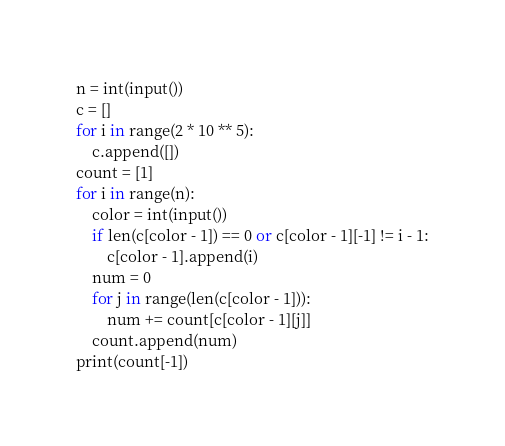Convert code to text. <code><loc_0><loc_0><loc_500><loc_500><_Python_>n = int(input())
c = []
for i in range(2 * 10 ** 5):
    c.append([])
count = [1]
for i in range(n):
    color = int(input())
    if len(c[color - 1]) == 0 or c[color - 1][-1] != i - 1:
        c[color - 1].append(i)
    num = 0
    for j in range(len(c[color - 1])):
        num += count[c[color - 1][j]]
    count.append(num)
print(count[-1])</code> 